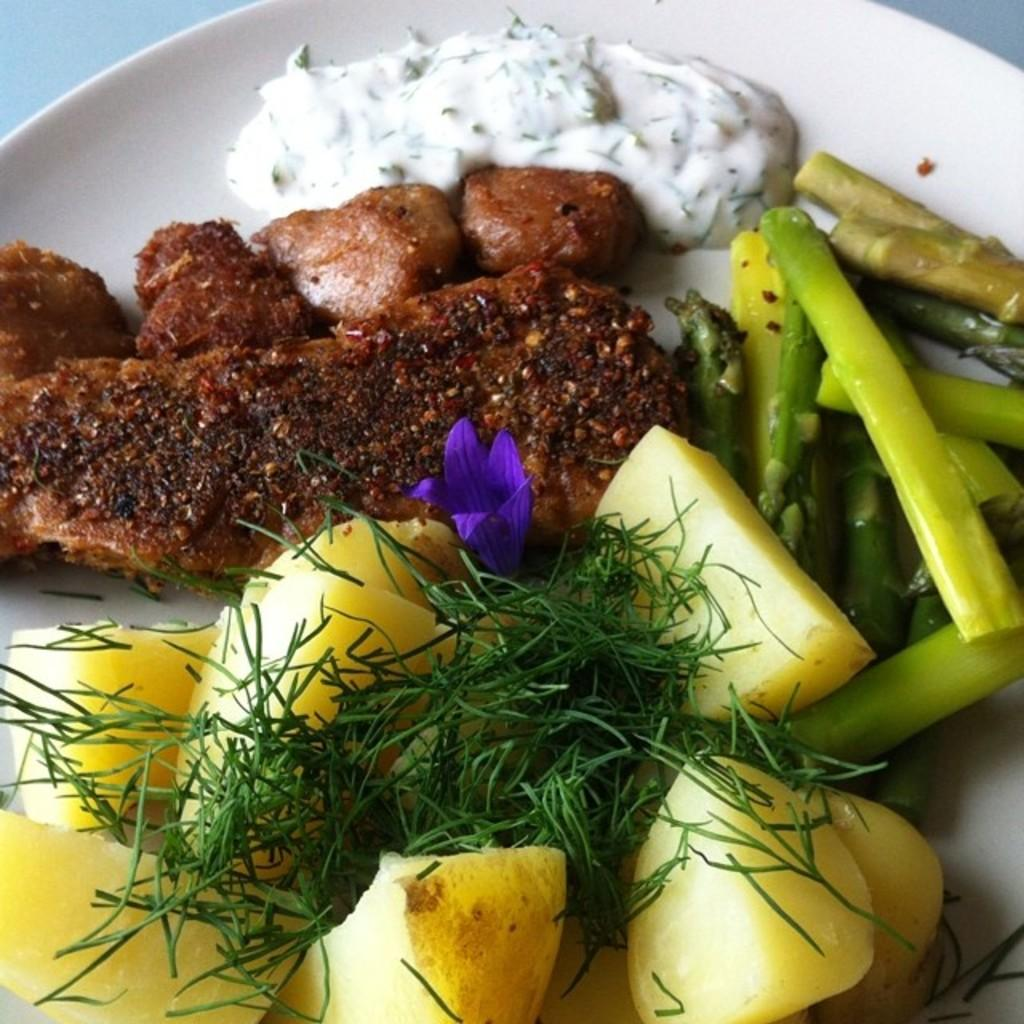What types of items can be seen in the image? There are food items and a flower in the image. How are the food items and flower arranged in the image? The food items and flower are in a plate. What color is the background of the image? The background of the image is white. What type of box is being used to store the memory in the image? There is no box or memory present in the image; it features food items and a flower in a plate with a white background. 